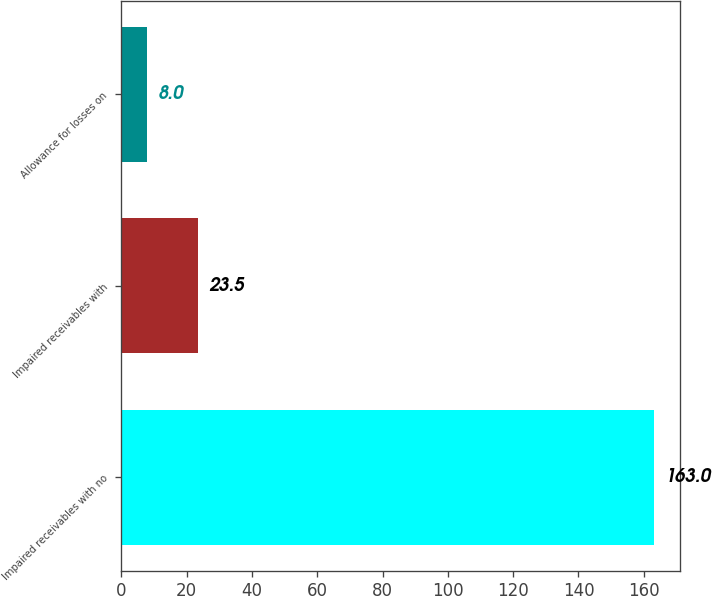Convert chart. <chart><loc_0><loc_0><loc_500><loc_500><bar_chart><fcel>Impaired receivables with no<fcel>Impaired receivables with<fcel>Allowance for losses on<nl><fcel>163<fcel>23.5<fcel>8<nl></chart> 